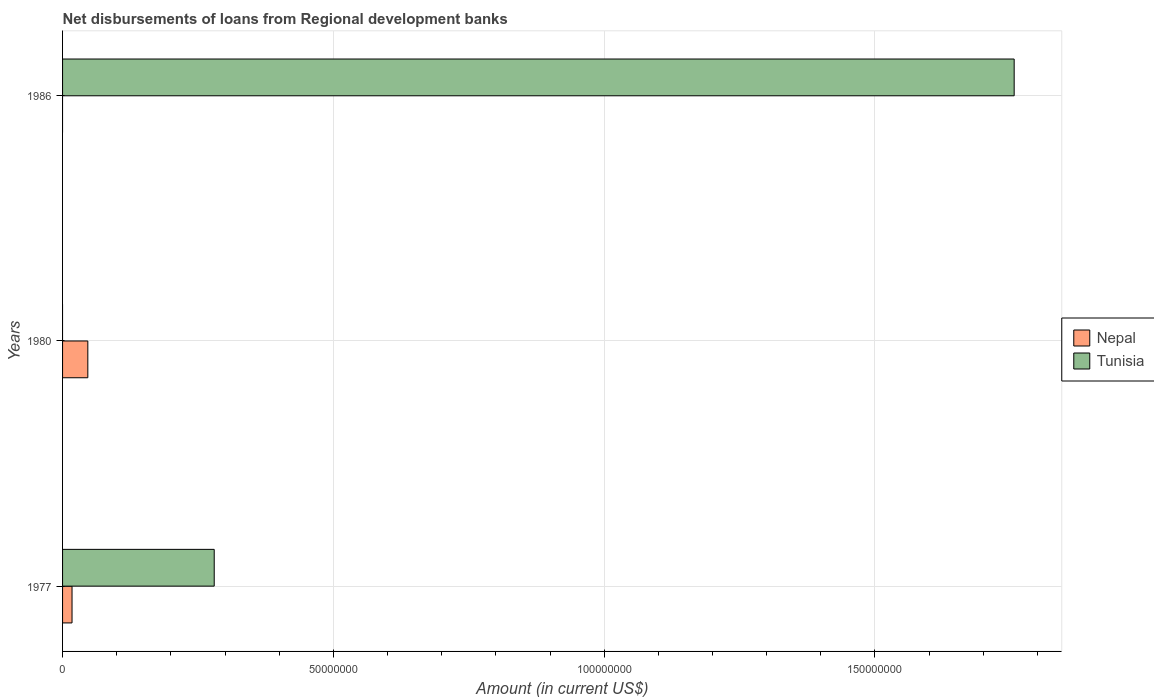How many different coloured bars are there?
Offer a very short reply. 2. How many bars are there on the 2nd tick from the top?
Make the answer very short. 1. What is the label of the 1st group of bars from the top?
Keep it short and to the point. 1986. In how many cases, is the number of bars for a given year not equal to the number of legend labels?
Your answer should be very brief. 2. What is the amount of disbursements of loans from regional development banks in Tunisia in 1977?
Provide a succinct answer. 2.80e+07. Across all years, what is the maximum amount of disbursements of loans from regional development banks in Tunisia?
Offer a terse response. 1.76e+08. What is the total amount of disbursements of loans from regional development banks in Nepal in the graph?
Your answer should be very brief. 6.41e+06. What is the difference between the amount of disbursements of loans from regional development banks in Tunisia in 1977 and that in 1986?
Provide a short and direct response. -1.48e+08. What is the difference between the amount of disbursements of loans from regional development banks in Nepal in 1977 and the amount of disbursements of loans from regional development banks in Tunisia in 1986?
Make the answer very short. -1.74e+08. What is the average amount of disbursements of loans from regional development banks in Nepal per year?
Make the answer very short. 2.14e+06. In the year 1977, what is the difference between the amount of disbursements of loans from regional development banks in Tunisia and amount of disbursements of loans from regional development banks in Nepal?
Ensure brevity in your answer.  2.63e+07. In how many years, is the amount of disbursements of loans from regional development banks in Tunisia greater than 130000000 US$?
Provide a succinct answer. 1. What is the ratio of the amount of disbursements of loans from regional development banks in Nepal in 1977 to that in 1980?
Your answer should be very brief. 0.37. Is the amount of disbursements of loans from regional development banks in Nepal in 1977 less than that in 1980?
Offer a terse response. Yes. What is the difference between the highest and the lowest amount of disbursements of loans from regional development banks in Tunisia?
Make the answer very short. 1.76e+08. Are all the bars in the graph horizontal?
Provide a succinct answer. Yes. What is the difference between two consecutive major ticks on the X-axis?
Give a very brief answer. 5.00e+07. Are the values on the major ticks of X-axis written in scientific E-notation?
Your response must be concise. No. Does the graph contain any zero values?
Your response must be concise. Yes. How are the legend labels stacked?
Your response must be concise. Vertical. What is the title of the graph?
Offer a very short reply. Net disbursements of loans from Regional development banks. What is the label or title of the Y-axis?
Keep it short and to the point. Years. What is the Amount (in current US$) in Nepal in 1977?
Give a very brief answer. 1.75e+06. What is the Amount (in current US$) in Tunisia in 1977?
Your response must be concise. 2.80e+07. What is the Amount (in current US$) of Nepal in 1980?
Keep it short and to the point. 4.66e+06. What is the Amount (in current US$) in Tunisia in 1986?
Provide a short and direct response. 1.76e+08. Across all years, what is the maximum Amount (in current US$) of Nepal?
Keep it short and to the point. 4.66e+06. Across all years, what is the maximum Amount (in current US$) in Tunisia?
Provide a succinct answer. 1.76e+08. Across all years, what is the minimum Amount (in current US$) of Nepal?
Provide a short and direct response. 0. What is the total Amount (in current US$) of Nepal in the graph?
Keep it short and to the point. 6.41e+06. What is the total Amount (in current US$) of Tunisia in the graph?
Make the answer very short. 2.04e+08. What is the difference between the Amount (in current US$) in Nepal in 1977 and that in 1980?
Provide a short and direct response. -2.92e+06. What is the difference between the Amount (in current US$) of Tunisia in 1977 and that in 1986?
Give a very brief answer. -1.48e+08. What is the difference between the Amount (in current US$) of Nepal in 1977 and the Amount (in current US$) of Tunisia in 1986?
Ensure brevity in your answer.  -1.74e+08. What is the difference between the Amount (in current US$) of Nepal in 1980 and the Amount (in current US$) of Tunisia in 1986?
Keep it short and to the point. -1.71e+08. What is the average Amount (in current US$) of Nepal per year?
Keep it short and to the point. 2.14e+06. What is the average Amount (in current US$) in Tunisia per year?
Offer a very short reply. 6.79e+07. In the year 1977, what is the difference between the Amount (in current US$) in Nepal and Amount (in current US$) in Tunisia?
Provide a short and direct response. -2.63e+07. What is the ratio of the Amount (in current US$) in Nepal in 1977 to that in 1980?
Give a very brief answer. 0.37. What is the ratio of the Amount (in current US$) in Tunisia in 1977 to that in 1986?
Give a very brief answer. 0.16. What is the difference between the highest and the lowest Amount (in current US$) in Nepal?
Your response must be concise. 4.66e+06. What is the difference between the highest and the lowest Amount (in current US$) of Tunisia?
Your answer should be very brief. 1.76e+08. 